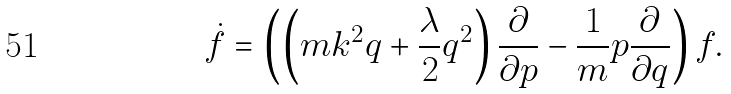Convert formula to latex. <formula><loc_0><loc_0><loc_500><loc_500>\dot { f } = \left ( \left ( m k ^ { 2 } q + \frac { \lambda } { 2 } q ^ { 2 } \right ) \frac { \partial } { \partial p } - \frac { 1 } { m } p \frac { \partial } { \partial q } \right ) f .</formula> 